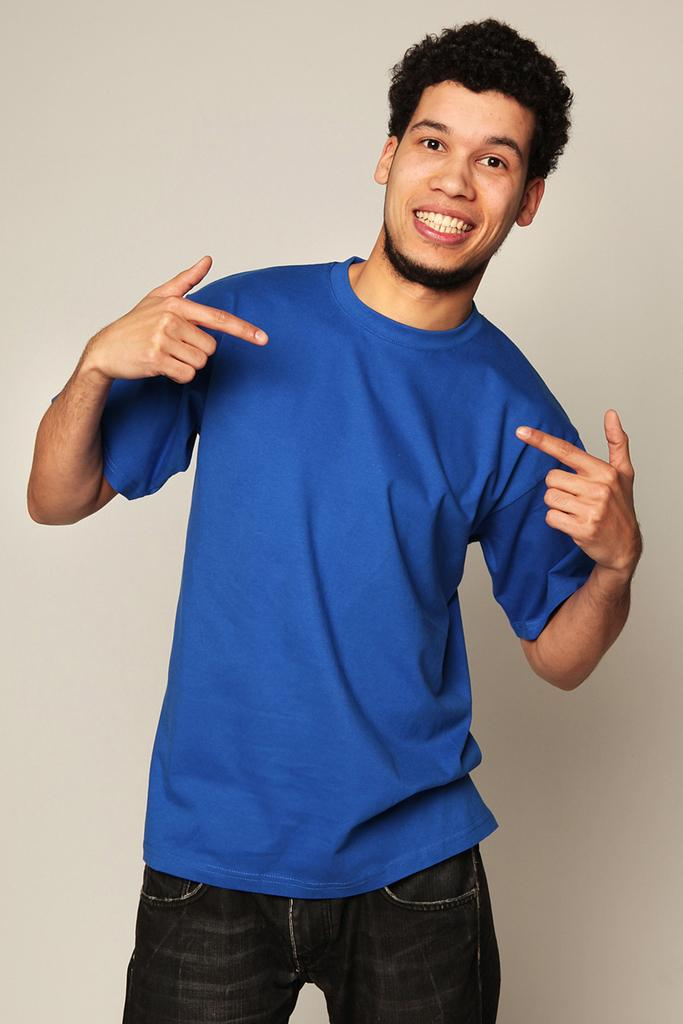Who is the person in the image? There is a man in the image. What can be seen in the background of the image? There is a wall in the background of the image. What type of industry is depicted in the image? There is no industry depicted in the image; it only features a man and a wall in the background. 